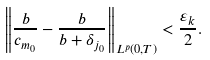<formula> <loc_0><loc_0><loc_500><loc_500>\left \| \frac { b } { c _ { m _ { 0 } } } - \frac { b } { b + \delta _ { j _ { 0 } } } \right \| _ { L ^ { p } ( 0 , T ) } < \frac { \varepsilon _ { k } } { 2 } .</formula> 